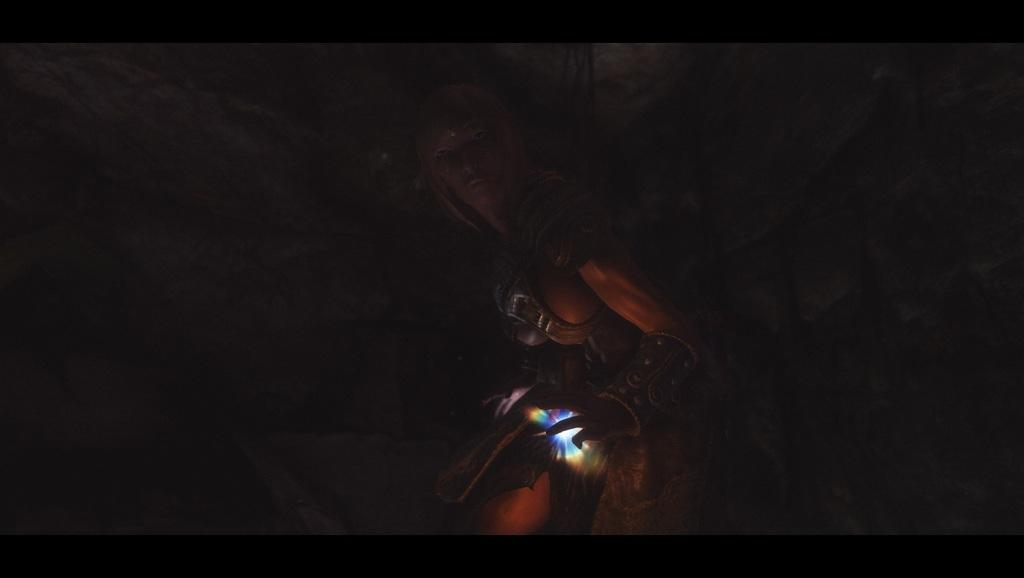What is the main subject of the image? The main subject of the image is a sculpture of a person. What is the sculpture holding in the image? The sculpture is holding a light in the image. How would you describe the background of the image? The background of the image is dark in color. What type of tooth is visible in the image? There is no tooth present in the image; it features a sculpture of a person holding a light. Who is the creator of the shop in the image? There is no shop present in the image, so it is not possible to determine the creator. 